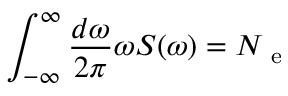<formula> <loc_0><loc_0><loc_500><loc_500>\int _ { - \infty } ^ { \infty } \frac { d \omega } { 2 \pi } \omega S ( \omega ) = N _ { e }</formula> 